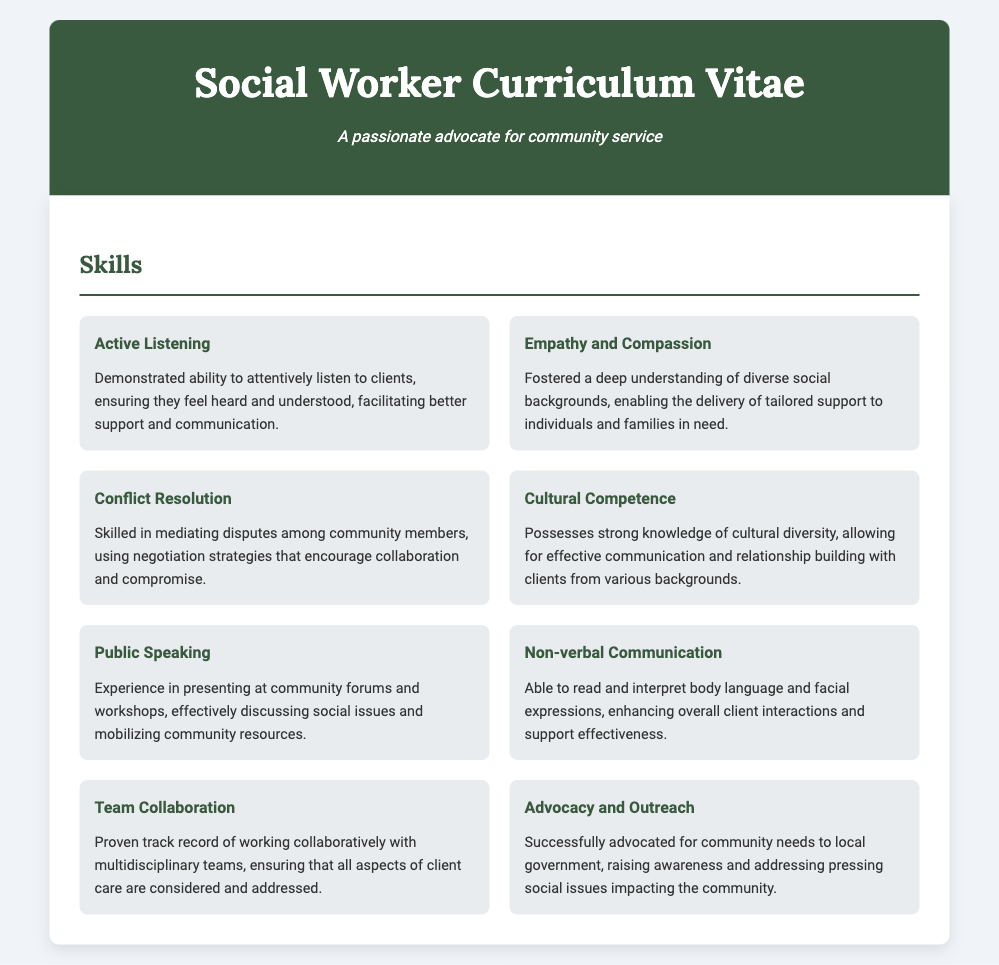What is the title of the document? The title of the document appears in the header of the CV and is "Social Worker Curriculum Vitae."
Answer: Social Worker Curriculum Vitae How many skills are listed in the Skills section? The Skills section lists a total of eight skills.
Answer: 8 What is highlighted as a key ability under 'Active Listening'? The description mentions the ability to "attentively listen to clients, ensuring they feel heard and understood."
Answer: attentively listen to clients Which skill emphasizes the importance of understanding diverse social backgrounds? The skill emphasizing this is "Empathy and Compassion."
Answer: Empathy and Compassion What type of communication skill is listed that involves body language? The skill that involves body language is "Non-verbal Communication."
Answer: Non-verbal Communication Under which skill does public engagement and awareness raising appear? The skill related to public engagement is "Advocacy and Outreach."
Answer: Advocacy and Outreach What color is used for the header background in the CV? The header background color is "#3a5a40."
Answer: #3a5a40 Which skill corresponds to working with multidisciplinary teams? The skill related to this is "Team Collaboration."
Answer: Team Collaboration 